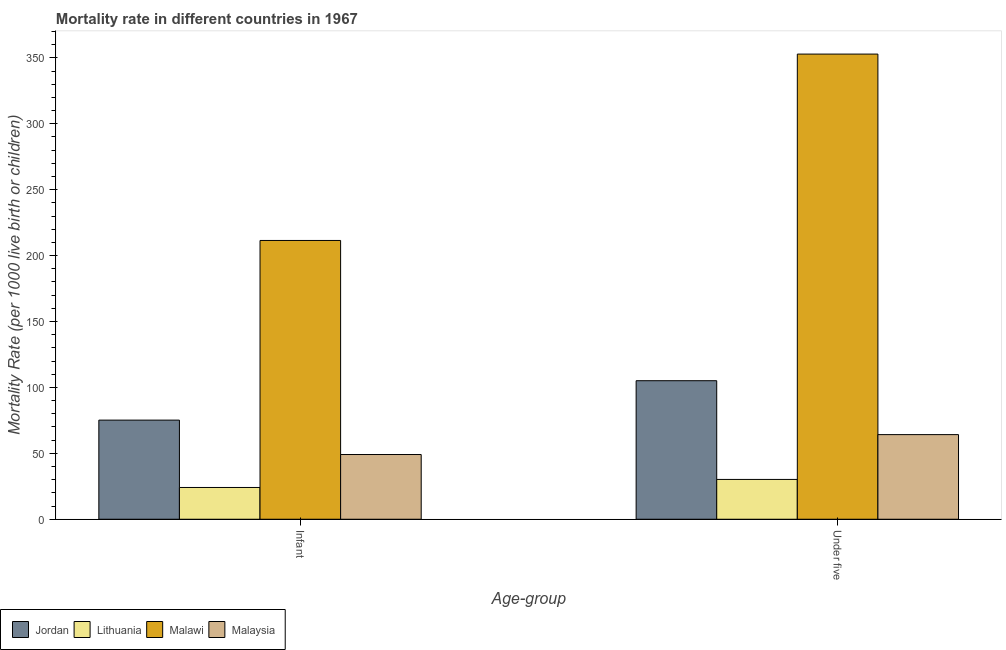How many different coloured bars are there?
Give a very brief answer. 4. Are the number of bars on each tick of the X-axis equal?
Keep it short and to the point. Yes. What is the label of the 1st group of bars from the left?
Provide a short and direct response. Infant. What is the under-5 mortality rate in Malawi?
Your response must be concise. 352.9. Across all countries, what is the maximum under-5 mortality rate?
Make the answer very short. 352.9. Across all countries, what is the minimum infant mortality rate?
Keep it short and to the point. 24.1. In which country was the infant mortality rate maximum?
Make the answer very short. Malawi. In which country was the under-5 mortality rate minimum?
Provide a succinct answer. Lithuania. What is the total under-5 mortality rate in the graph?
Provide a succinct answer. 552.4. What is the difference between the infant mortality rate in Lithuania and that in Malawi?
Offer a very short reply. -187.4. What is the difference between the under-5 mortality rate in Malawi and the infant mortality rate in Jordan?
Offer a very short reply. 277.7. What is the average under-5 mortality rate per country?
Provide a succinct answer. 138.1. What is the difference between the infant mortality rate and under-5 mortality rate in Malawi?
Your response must be concise. -141.4. In how many countries, is the infant mortality rate greater than 170 ?
Provide a succinct answer. 1. What is the ratio of the infant mortality rate in Malawi to that in Lithuania?
Your answer should be very brief. 8.78. In how many countries, is the under-5 mortality rate greater than the average under-5 mortality rate taken over all countries?
Ensure brevity in your answer.  1. What does the 4th bar from the left in Under five represents?
Keep it short and to the point. Malaysia. What does the 3rd bar from the right in Infant represents?
Your response must be concise. Lithuania. Are all the bars in the graph horizontal?
Your answer should be very brief. No. What is the difference between two consecutive major ticks on the Y-axis?
Your answer should be very brief. 50. Does the graph contain any zero values?
Give a very brief answer. No. Does the graph contain grids?
Your response must be concise. No. How many legend labels are there?
Provide a succinct answer. 4. What is the title of the graph?
Your response must be concise. Mortality rate in different countries in 1967. What is the label or title of the X-axis?
Your answer should be very brief. Age-group. What is the label or title of the Y-axis?
Offer a terse response. Mortality Rate (per 1000 live birth or children). What is the Mortality Rate (per 1000 live birth or children) of Jordan in Infant?
Keep it short and to the point. 75.2. What is the Mortality Rate (per 1000 live birth or children) in Lithuania in Infant?
Provide a succinct answer. 24.1. What is the Mortality Rate (per 1000 live birth or children) in Malawi in Infant?
Offer a very short reply. 211.5. What is the Mortality Rate (per 1000 live birth or children) of Malaysia in Infant?
Your answer should be very brief. 49.1. What is the Mortality Rate (per 1000 live birth or children) of Jordan in Under five?
Offer a terse response. 105.1. What is the Mortality Rate (per 1000 live birth or children) of Lithuania in Under five?
Ensure brevity in your answer.  30.2. What is the Mortality Rate (per 1000 live birth or children) of Malawi in Under five?
Your answer should be very brief. 352.9. What is the Mortality Rate (per 1000 live birth or children) of Malaysia in Under five?
Provide a short and direct response. 64.2. Across all Age-group, what is the maximum Mortality Rate (per 1000 live birth or children) of Jordan?
Offer a terse response. 105.1. Across all Age-group, what is the maximum Mortality Rate (per 1000 live birth or children) of Lithuania?
Make the answer very short. 30.2. Across all Age-group, what is the maximum Mortality Rate (per 1000 live birth or children) in Malawi?
Your answer should be compact. 352.9. Across all Age-group, what is the maximum Mortality Rate (per 1000 live birth or children) in Malaysia?
Your response must be concise. 64.2. Across all Age-group, what is the minimum Mortality Rate (per 1000 live birth or children) of Jordan?
Ensure brevity in your answer.  75.2. Across all Age-group, what is the minimum Mortality Rate (per 1000 live birth or children) of Lithuania?
Give a very brief answer. 24.1. Across all Age-group, what is the minimum Mortality Rate (per 1000 live birth or children) in Malawi?
Give a very brief answer. 211.5. Across all Age-group, what is the minimum Mortality Rate (per 1000 live birth or children) of Malaysia?
Your response must be concise. 49.1. What is the total Mortality Rate (per 1000 live birth or children) in Jordan in the graph?
Give a very brief answer. 180.3. What is the total Mortality Rate (per 1000 live birth or children) of Lithuania in the graph?
Give a very brief answer. 54.3. What is the total Mortality Rate (per 1000 live birth or children) in Malawi in the graph?
Offer a terse response. 564.4. What is the total Mortality Rate (per 1000 live birth or children) of Malaysia in the graph?
Your response must be concise. 113.3. What is the difference between the Mortality Rate (per 1000 live birth or children) in Jordan in Infant and that in Under five?
Provide a short and direct response. -29.9. What is the difference between the Mortality Rate (per 1000 live birth or children) of Malawi in Infant and that in Under five?
Provide a short and direct response. -141.4. What is the difference between the Mortality Rate (per 1000 live birth or children) in Malaysia in Infant and that in Under five?
Give a very brief answer. -15.1. What is the difference between the Mortality Rate (per 1000 live birth or children) in Jordan in Infant and the Mortality Rate (per 1000 live birth or children) in Lithuania in Under five?
Keep it short and to the point. 45. What is the difference between the Mortality Rate (per 1000 live birth or children) in Jordan in Infant and the Mortality Rate (per 1000 live birth or children) in Malawi in Under five?
Ensure brevity in your answer.  -277.7. What is the difference between the Mortality Rate (per 1000 live birth or children) of Jordan in Infant and the Mortality Rate (per 1000 live birth or children) of Malaysia in Under five?
Your answer should be compact. 11. What is the difference between the Mortality Rate (per 1000 live birth or children) in Lithuania in Infant and the Mortality Rate (per 1000 live birth or children) in Malawi in Under five?
Your answer should be compact. -328.8. What is the difference between the Mortality Rate (per 1000 live birth or children) in Lithuania in Infant and the Mortality Rate (per 1000 live birth or children) in Malaysia in Under five?
Ensure brevity in your answer.  -40.1. What is the difference between the Mortality Rate (per 1000 live birth or children) in Malawi in Infant and the Mortality Rate (per 1000 live birth or children) in Malaysia in Under five?
Your response must be concise. 147.3. What is the average Mortality Rate (per 1000 live birth or children) in Jordan per Age-group?
Provide a short and direct response. 90.15. What is the average Mortality Rate (per 1000 live birth or children) of Lithuania per Age-group?
Provide a succinct answer. 27.15. What is the average Mortality Rate (per 1000 live birth or children) of Malawi per Age-group?
Provide a succinct answer. 282.2. What is the average Mortality Rate (per 1000 live birth or children) of Malaysia per Age-group?
Provide a short and direct response. 56.65. What is the difference between the Mortality Rate (per 1000 live birth or children) of Jordan and Mortality Rate (per 1000 live birth or children) of Lithuania in Infant?
Provide a short and direct response. 51.1. What is the difference between the Mortality Rate (per 1000 live birth or children) in Jordan and Mortality Rate (per 1000 live birth or children) in Malawi in Infant?
Your response must be concise. -136.3. What is the difference between the Mortality Rate (per 1000 live birth or children) in Jordan and Mortality Rate (per 1000 live birth or children) in Malaysia in Infant?
Offer a very short reply. 26.1. What is the difference between the Mortality Rate (per 1000 live birth or children) of Lithuania and Mortality Rate (per 1000 live birth or children) of Malawi in Infant?
Keep it short and to the point. -187.4. What is the difference between the Mortality Rate (per 1000 live birth or children) of Malawi and Mortality Rate (per 1000 live birth or children) of Malaysia in Infant?
Offer a terse response. 162.4. What is the difference between the Mortality Rate (per 1000 live birth or children) of Jordan and Mortality Rate (per 1000 live birth or children) of Lithuania in Under five?
Your answer should be compact. 74.9. What is the difference between the Mortality Rate (per 1000 live birth or children) in Jordan and Mortality Rate (per 1000 live birth or children) in Malawi in Under five?
Your answer should be very brief. -247.8. What is the difference between the Mortality Rate (per 1000 live birth or children) in Jordan and Mortality Rate (per 1000 live birth or children) in Malaysia in Under five?
Offer a very short reply. 40.9. What is the difference between the Mortality Rate (per 1000 live birth or children) in Lithuania and Mortality Rate (per 1000 live birth or children) in Malawi in Under five?
Offer a very short reply. -322.7. What is the difference between the Mortality Rate (per 1000 live birth or children) in Lithuania and Mortality Rate (per 1000 live birth or children) in Malaysia in Under five?
Keep it short and to the point. -34. What is the difference between the Mortality Rate (per 1000 live birth or children) of Malawi and Mortality Rate (per 1000 live birth or children) of Malaysia in Under five?
Your response must be concise. 288.7. What is the ratio of the Mortality Rate (per 1000 live birth or children) of Jordan in Infant to that in Under five?
Your answer should be compact. 0.72. What is the ratio of the Mortality Rate (per 1000 live birth or children) of Lithuania in Infant to that in Under five?
Keep it short and to the point. 0.8. What is the ratio of the Mortality Rate (per 1000 live birth or children) in Malawi in Infant to that in Under five?
Make the answer very short. 0.6. What is the ratio of the Mortality Rate (per 1000 live birth or children) of Malaysia in Infant to that in Under five?
Keep it short and to the point. 0.76. What is the difference between the highest and the second highest Mortality Rate (per 1000 live birth or children) of Jordan?
Your answer should be very brief. 29.9. What is the difference between the highest and the second highest Mortality Rate (per 1000 live birth or children) of Malawi?
Ensure brevity in your answer.  141.4. What is the difference between the highest and the lowest Mortality Rate (per 1000 live birth or children) in Jordan?
Give a very brief answer. 29.9. What is the difference between the highest and the lowest Mortality Rate (per 1000 live birth or children) of Lithuania?
Your answer should be compact. 6.1. What is the difference between the highest and the lowest Mortality Rate (per 1000 live birth or children) of Malawi?
Give a very brief answer. 141.4. 